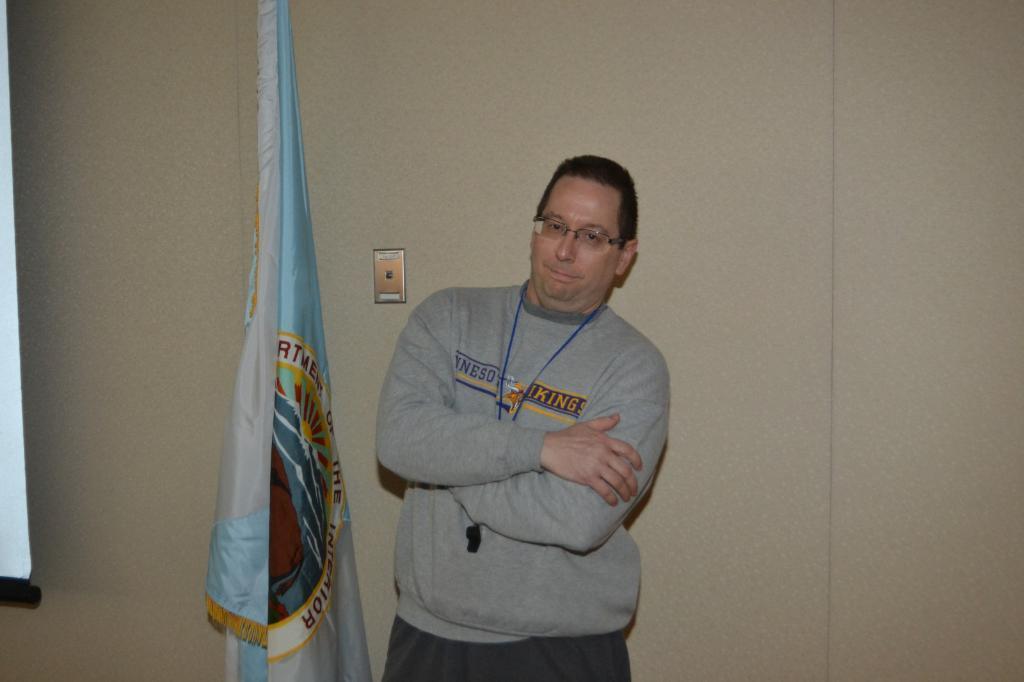Describe this image in one or two sentences. In the image we can see the person who is standing in the middle, he is wearing a jacket and glasses. There is a whistle around his neck. Behind him there is a wall which is of cream colour. Beside the person there is a flag. 